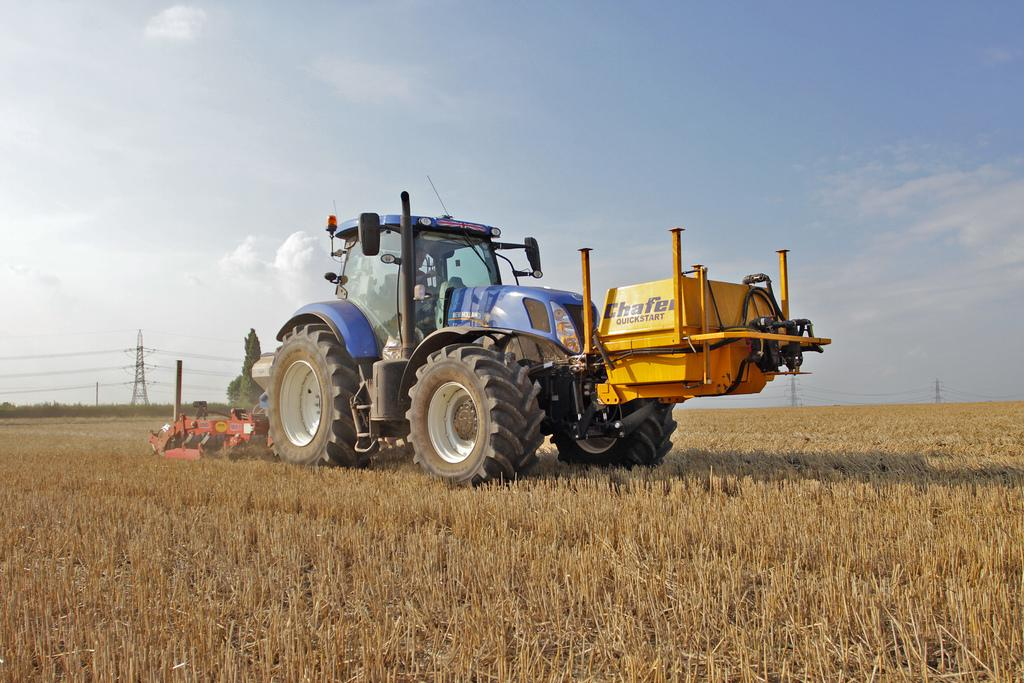What is the person in the image doing? There is a person sitting in a tractor. What can be seen behind the tractor in the image? There are electric poles with cables behind the tractor. What is visible in the background of the image? The sky is visible behind the electric poles. How many bikes are parked next to the tractor in the image? There are no bikes present in the image. What type of hope can be seen in the person's expression in the image? The image does not show the person's expression, so it cannot be determined if there is any hope present. 